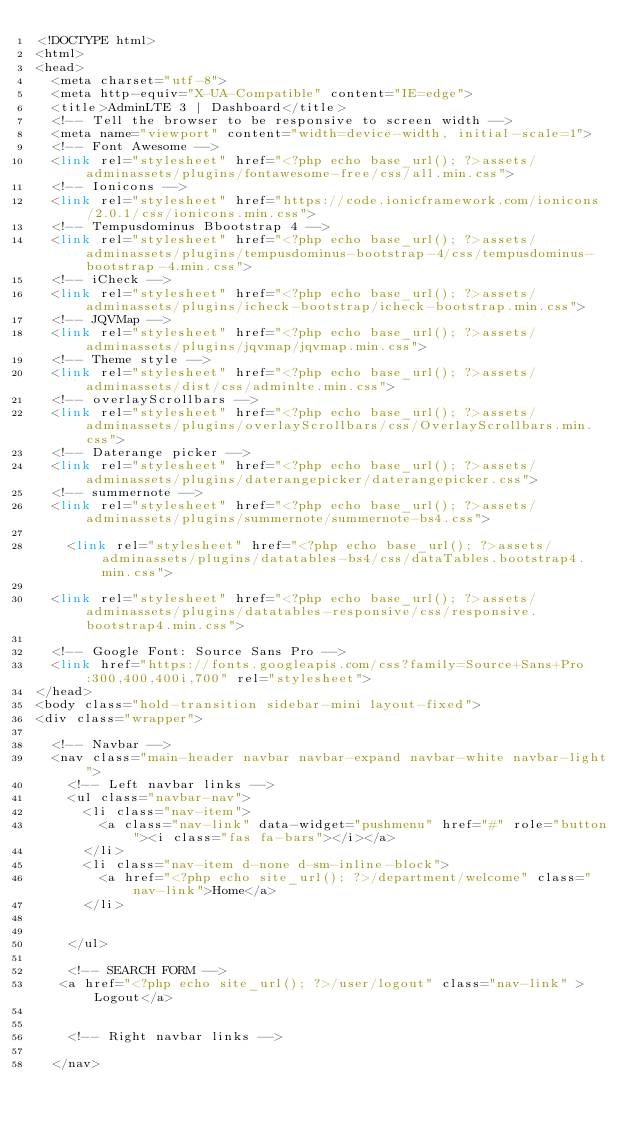Convert code to text. <code><loc_0><loc_0><loc_500><loc_500><_PHP_><!DOCTYPE html>
<html>
<head>
  <meta charset="utf-8">
  <meta http-equiv="X-UA-Compatible" content="IE=edge">
  <title>AdminLTE 3 | Dashboard</title>
  <!-- Tell the browser to be responsive to screen width -->
  <meta name="viewport" content="width=device-width, initial-scale=1">
  <!-- Font Awesome -->
  <link rel="stylesheet" href="<?php echo base_url(); ?>assets/adminassets/plugins/fontawesome-free/css/all.min.css">
  <!-- Ionicons -->
  <link rel="stylesheet" href="https://code.ionicframework.com/ionicons/2.0.1/css/ionicons.min.css">
  <!-- Tempusdominus Bbootstrap 4 -->
  <link rel="stylesheet" href="<?php echo base_url(); ?>assets/adminassets/plugins/tempusdominus-bootstrap-4/css/tempusdominus-bootstrap-4.min.css">
  <!-- iCheck -->
  <link rel="stylesheet" href="<?php echo base_url(); ?>assets/adminassets/plugins/icheck-bootstrap/icheck-bootstrap.min.css">
  <!-- JQVMap -->
  <link rel="stylesheet" href="<?php echo base_url(); ?>assets/adminassets/plugins/jqvmap/jqvmap.min.css">
  <!-- Theme style -->
  <link rel="stylesheet" href="<?php echo base_url(); ?>assets/adminassets/dist/css/adminlte.min.css">
  <!-- overlayScrollbars -->
  <link rel="stylesheet" href="<?php echo base_url(); ?>assets/adminassets/plugins/overlayScrollbars/css/OverlayScrollbars.min.css">
  <!-- Daterange picker -->
  <link rel="stylesheet" href="<?php echo base_url(); ?>assets/adminassets/plugins/daterangepicker/daterangepicker.css">
  <!-- summernote -->
  <link rel="stylesheet" href="<?php echo base_url(); ?>assets/adminassets/plugins/summernote/summernote-bs4.css">
	
	<link rel="stylesheet" href="<?php echo base_url(); ?>assets/adminassets/plugins/datatables-bs4/css/dataTables.bootstrap4.min.css">
	
  <link rel="stylesheet" href="<?php echo base_url(); ?>assets/adminassets/plugins/datatables-responsive/css/responsive.bootstrap4.min.css">
	
  <!-- Google Font: Source Sans Pro -->
  <link href="https://fonts.googleapis.com/css?family=Source+Sans+Pro:300,400,400i,700" rel="stylesheet">
</head>
<body class="hold-transition sidebar-mini layout-fixed">
<div class="wrapper">

  <!-- Navbar -->
  <nav class="main-header navbar navbar-expand navbar-white navbar-light">
    <!-- Left navbar links -->
    <ul class="navbar-nav">
      <li class="nav-item">
        <a class="nav-link" data-widget="pushmenu" href="#" role="button"><i class="fas fa-bars"></i></a>
      </li>
      <li class="nav-item d-none d-sm-inline-block">
        <a href="<?php echo site_url(); ?>/department/welcome" class="nav-link">Home</a>
      </li>
      
		 
    </ul>
	
    <!-- SEARCH FORM -->
   <a href="<?php echo site_url(); ?>/user/logout" class="nav-link" >Logout</a>
	   

    <!-- Right navbar links -->
    
  </nav></code> 